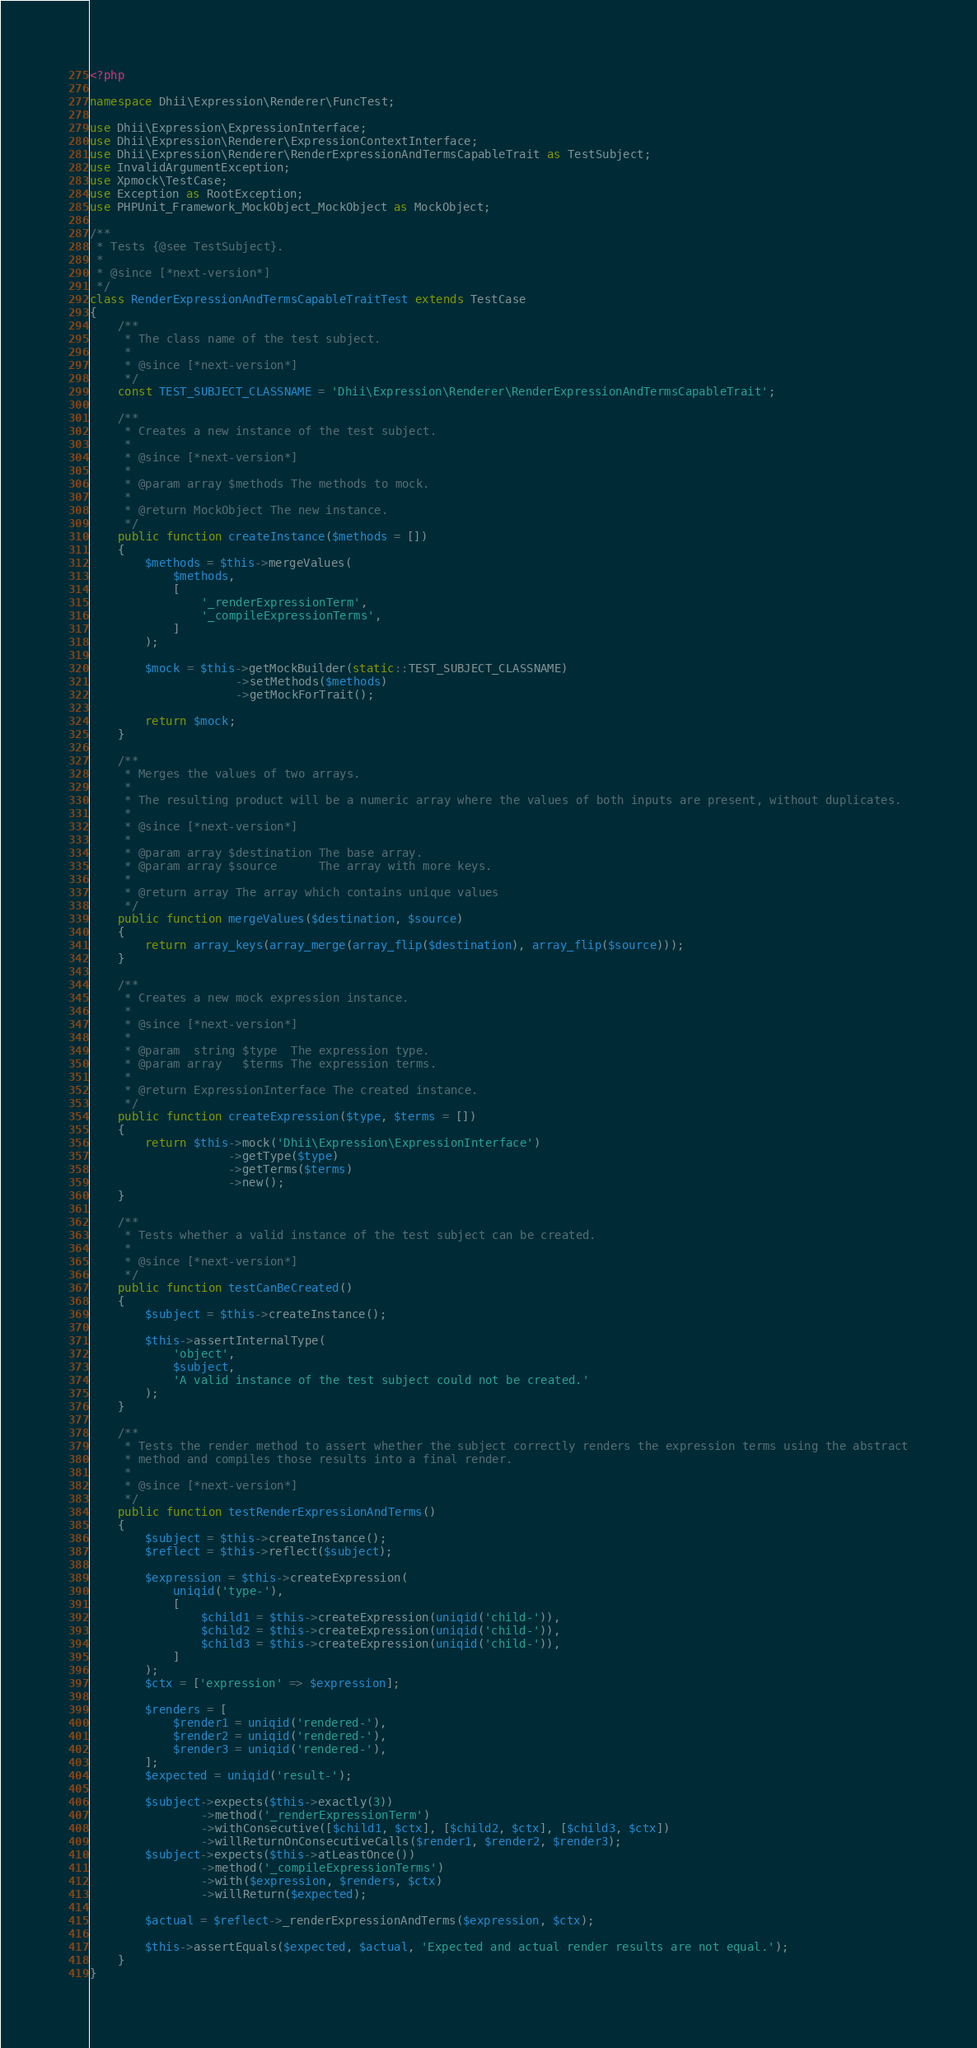Convert code to text. <code><loc_0><loc_0><loc_500><loc_500><_PHP_><?php

namespace Dhii\Expression\Renderer\FuncTest;

use Dhii\Expression\ExpressionInterface;
use Dhii\Expression\Renderer\ExpressionContextInterface;
use Dhii\Expression\Renderer\RenderExpressionAndTermsCapableTrait as TestSubject;
use InvalidArgumentException;
use Xpmock\TestCase;
use Exception as RootException;
use PHPUnit_Framework_MockObject_MockObject as MockObject;

/**
 * Tests {@see TestSubject}.
 *
 * @since [*next-version*]
 */
class RenderExpressionAndTermsCapableTraitTest extends TestCase
{
    /**
     * The class name of the test subject.
     *
     * @since [*next-version*]
     */
    const TEST_SUBJECT_CLASSNAME = 'Dhii\Expression\Renderer\RenderExpressionAndTermsCapableTrait';

    /**
     * Creates a new instance of the test subject.
     *
     * @since [*next-version*]
     *
     * @param array $methods The methods to mock.
     *
     * @return MockObject The new instance.
     */
    public function createInstance($methods = [])
    {
        $methods = $this->mergeValues(
            $methods,
            [
                '_renderExpressionTerm',
                '_compileExpressionTerms',
            ]
        );

        $mock = $this->getMockBuilder(static::TEST_SUBJECT_CLASSNAME)
                     ->setMethods($methods)
                     ->getMockForTrait();

        return $mock;
    }

    /**
     * Merges the values of two arrays.
     *
     * The resulting product will be a numeric array where the values of both inputs are present, without duplicates.
     *
     * @since [*next-version*]
     *
     * @param array $destination The base array.
     * @param array $source      The array with more keys.
     *
     * @return array The array which contains unique values
     */
    public function mergeValues($destination, $source)
    {
        return array_keys(array_merge(array_flip($destination), array_flip($source)));
    }

    /**
     * Creates a new mock expression instance.
     *
     * @since [*next-version*]
     *
     * @param  string $type  The expression type.
     * @param array   $terms The expression terms.
     *
     * @return ExpressionInterface The created instance.
     */
    public function createExpression($type, $terms = [])
    {
        return $this->mock('Dhii\Expression\ExpressionInterface')
                    ->getType($type)
                    ->getTerms($terms)
                    ->new();
    }

    /**
     * Tests whether a valid instance of the test subject can be created.
     *
     * @since [*next-version*]
     */
    public function testCanBeCreated()
    {
        $subject = $this->createInstance();

        $this->assertInternalType(
            'object',
            $subject,
            'A valid instance of the test subject could not be created.'
        );
    }

    /**
     * Tests the render method to assert whether the subject correctly renders the expression terms using the abstract
     * method and compiles those results into a final render.
     *
     * @since [*next-version*]
     */
    public function testRenderExpressionAndTerms()
    {
        $subject = $this->createInstance();
        $reflect = $this->reflect($subject);

        $expression = $this->createExpression(
            uniqid('type-'),
            [
                $child1 = $this->createExpression(uniqid('child-')),
                $child2 = $this->createExpression(uniqid('child-')),
                $child3 = $this->createExpression(uniqid('child-')),
            ]
        );
        $ctx = ['expression' => $expression];

        $renders = [
            $render1 = uniqid('rendered-'),
            $render2 = uniqid('rendered-'),
            $render3 = uniqid('rendered-'),
        ];
        $expected = uniqid('result-');

        $subject->expects($this->exactly(3))
                ->method('_renderExpressionTerm')
                ->withConsecutive([$child1, $ctx], [$child2, $ctx], [$child3, $ctx])
                ->willReturnOnConsecutiveCalls($render1, $render2, $render3);
        $subject->expects($this->atLeastOnce())
                ->method('_compileExpressionTerms')
                ->with($expression, $renders, $ctx)
                ->willReturn($expected);

        $actual = $reflect->_renderExpressionAndTerms($expression, $ctx);

        $this->assertEquals($expected, $actual, 'Expected and actual render results are not equal.');
    }
}
</code> 